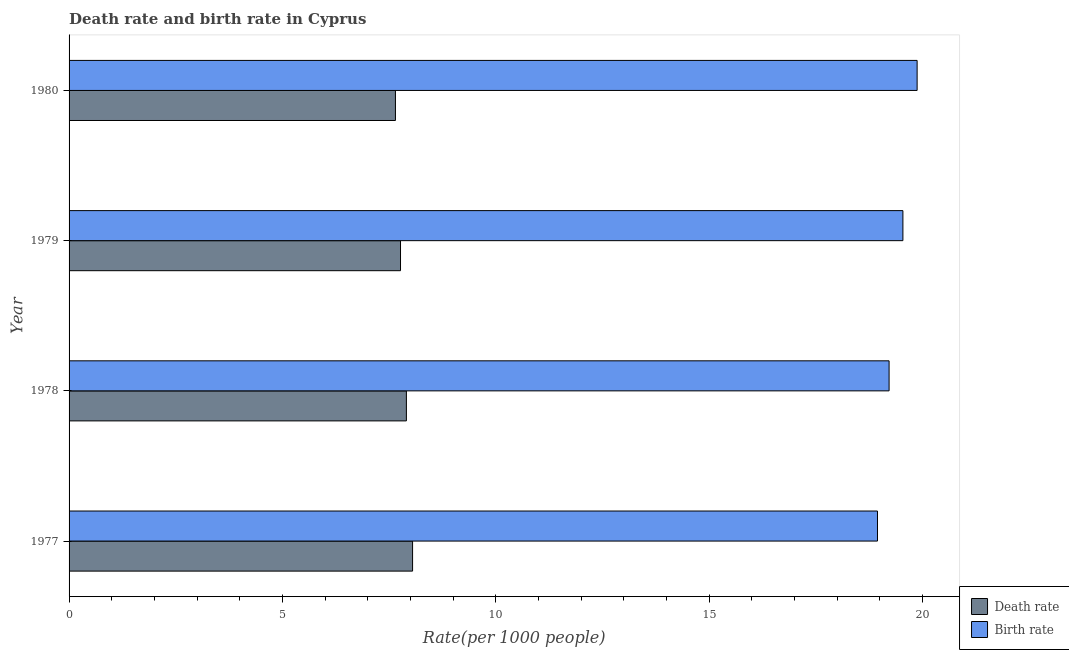Are the number of bars per tick equal to the number of legend labels?
Keep it short and to the point. Yes. Are the number of bars on each tick of the Y-axis equal?
Ensure brevity in your answer.  Yes. How many bars are there on the 2nd tick from the top?
Give a very brief answer. 2. What is the label of the 4th group of bars from the top?
Make the answer very short. 1977. What is the death rate in 1977?
Ensure brevity in your answer.  8.05. Across all years, what is the maximum birth rate?
Provide a short and direct response. 19.88. Across all years, what is the minimum birth rate?
Offer a very short reply. 18.95. In which year was the death rate minimum?
Your answer should be very brief. 1980. What is the total death rate in the graph?
Ensure brevity in your answer.  31.37. What is the difference between the birth rate in 1978 and that in 1979?
Provide a succinct answer. -0.32. What is the difference between the birth rate in 1980 and the death rate in 1978?
Provide a succinct answer. 11.97. What is the average death rate per year?
Provide a short and direct response. 7.84. In the year 1978, what is the difference between the death rate and birth rate?
Provide a short and direct response. -11.31. What is the ratio of the death rate in 1978 to that in 1979?
Offer a very short reply. 1.02. Is the difference between the birth rate in 1978 and 1980 greater than the difference between the death rate in 1978 and 1980?
Offer a very short reply. No. What is the difference between the highest and the second highest death rate?
Offer a terse response. 0.14. What is the difference between the highest and the lowest birth rate?
Your response must be concise. 0.93. In how many years, is the birth rate greater than the average birth rate taken over all years?
Your response must be concise. 2. What does the 1st bar from the top in 1979 represents?
Your response must be concise. Birth rate. What does the 2nd bar from the bottom in 1980 represents?
Offer a terse response. Birth rate. How many bars are there?
Keep it short and to the point. 8. Are all the bars in the graph horizontal?
Keep it short and to the point. Yes. Does the graph contain any zero values?
Ensure brevity in your answer.  No. Does the graph contain grids?
Your answer should be compact. No. What is the title of the graph?
Provide a short and direct response. Death rate and birth rate in Cyprus. What is the label or title of the X-axis?
Your answer should be very brief. Rate(per 1000 people). What is the label or title of the Y-axis?
Provide a short and direct response. Year. What is the Rate(per 1000 people) of Death rate in 1977?
Keep it short and to the point. 8.05. What is the Rate(per 1000 people) of Birth rate in 1977?
Give a very brief answer. 18.95. What is the Rate(per 1000 people) of Death rate in 1978?
Give a very brief answer. 7.91. What is the Rate(per 1000 people) of Birth rate in 1978?
Make the answer very short. 19.22. What is the Rate(per 1000 people) in Death rate in 1979?
Your answer should be compact. 7.77. What is the Rate(per 1000 people) in Birth rate in 1979?
Make the answer very short. 19.54. What is the Rate(per 1000 people) of Death rate in 1980?
Offer a terse response. 7.65. What is the Rate(per 1000 people) of Birth rate in 1980?
Offer a terse response. 19.88. Across all years, what is the maximum Rate(per 1000 people) in Death rate?
Provide a short and direct response. 8.05. Across all years, what is the maximum Rate(per 1000 people) in Birth rate?
Keep it short and to the point. 19.88. Across all years, what is the minimum Rate(per 1000 people) of Death rate?
Ensure brevity in your answer.  7.65. Across all years, what is the minimum Rate(per 1000 people) in Birth rate?
Provide a succinct answer. 18.95. What is the total Rate(per 1000 people) of Death rate in the graph?
Your response must be concise. 31.37. What is the total Rate(per 1000 people) of Birth rate in the graph?
Your answer should be compact. 77.58. What is the difference between the Rate(per 1000 people) in Death rate in 1977 and that in 1978?
Offer a terse response. 0.14. What is the difference between the Rate(per 1000 people) of Birth rate in 1977 and that in 1978?
Your response must be concise. -0.27. What is the difference between the Rate(per 1000 people) in Death rate in 1977 and that in 1979?
Give a very brief answer. 0.28. What is the difference between the Rate(per 1000 people) of Birth rate in 1977 and that in 1979?
Provide a short and direct response. -0.6. What is the difference between the Rate(per 1000 people) of Death rate in 1977 and that in 1980?
Offer a terse response. 0.4. What is the difference between the Rate(per 1000 people) in Birth rate in 1977 and that in 1980?
Your answer should be compact. -0.93. What is the difference between the Rate(per 1000 people) of Death rate in 1978 and that in 1979?
Offer a terse response. 0.14. What is the difference between the Rate(per 1000 people) of Birth rate in 1978 and that in 1979?
Your response must be concise. -0.32. What is the difference between the Rate(per 1000 people) in Death rate in 1978 and that in 1980?
Provide a short and direct response. 0.26. What is the difference between the Rate(per 1000 people) of Birth rate in 1978 and that in 1980?
Provide a succinct answer. -0.66. What is the difference between the Rate(per 1000 people) in Death rate in 1979 and that in 1980?
Ensure brevity in your answer.  0.12. What is the difference between the Rate(per 1000 people) of Birth rate in 1979 and that in 1980?
Provide a succinct answer. -0.33. What is the difference between the Rate(per 1000 people) of Death rate in 1977 and the Rate(per 1000 people) of Birth rate in 1978?
Ensure brevity in your answer.  -11.17. What is the difference between the Rate(per 1000 people) in Death rate in 1977 and the Rate(per 1000 people) in Birth rate in 1979?
Your response must be concise. -11.49. What is the difference between the Rate(per 1000 people) of Death rate in 1977 and the Rate(per 1000 people) of Birth rate in 1980?
Provide a short and direct response. -11.82. What is the difference between the Rate(per 1000 people) in Death rate in 1978 and the Rate(per 1000 people) in Birth rate in 1979?
Give a very brief answer. -11.64. What is the difference between the Rate(per 1000 people) of Death rate in 1978 and the Rate(per 1000 people) of Birth rate in 1980?
Offer a terse response. -11.97. What is the difference between the Rate(per 1000 people) in Death rate in 1979 and the Rate(per 1000 people) in Birth rate in 1980?
Give a very brief answer. -12.11. What is the average Rate(per 1000 people) in Death rate per year?
Your response must be concise. 7.84. What is the average Rate(per 1000 people) in Birth rate per year?
Make the answer very short. 19.4. In the year 1977, what is the difference between the Rate(per 1000 people) of Death rate and Rate(per 1000 people) of Birth rate?
Your response must be concise. -10.9. In the year 1978, what is the difference between the Rate(per 1000 people) of Death rate and Rate(per 1000 people) of Birth rate?
Offer a very short reply. -11.31. In the year 1979, what is the difference between the Rate(per 1000 people) of Death rate and Rate(per 1000 people) of Birth rate?
Provide a short and direct response. -11.78. In the year 1980, what is the difference between the Rate(per 1000 people) in Death rate and Rate(per 1000 people) in Birth rate?
Keep it short and to the point. -12.23. What is the ratio of the Rate(per 1000 people) of Death rate in 1977 to that in 1978?
Your answer should be compact. 1.02. What is the ratio of the Rate(per 1000 people) in Birth rate in 1977 to that in 1978?
Offer a very short reply. 0.99. What is the ratio of the Rate(per 1000 people) of Death rate in 1977 to that in 1979?
Ensure brevity in your answer.  1.04. What is the ratio of the Rate(per 1000 people) of Birth rate in 1977 to that in 1979?
Give a very brief answer. 0.97. What is the ratio of the Rate(per 1000 people) of Death rate in 1977 to that in 1980?
Your answer should be very brief. 1.05. What is the ratio of the Rate(per 1000 people) in Birth rate in 1977 to that in 1980?
Give a very brief answer. 0.95. What is the ratio of the Rate(per 1000 people) of Death rate in 1978 to that in 1979?
Provide a succinct answer. 1.02. What is the ratio of the Rate(per 1000 people) of Birth rate in 1978 to that in 1979?
Keep it short and to the point. 0.98. What is the ratio of the Rate(per 1000 people) in Death rate in 1978 to that in 1980?
Offer a terse response. 1.03. What is the ratio of the Rate(per 1000 people) in Birth rate in 1978 to that in 1980?
Your answer should be very brief. 0.97. What is the ratio of the Rate(per 1000 people) of Death rate in 1979 to that in 1980?
Provide a short and direct response. 1.02. What is the ratio of the Rate(per 1000 people) in Birth rate in 1979 to that in 1980?
Your response must be concise. 0.98. What is the difference between the highest and the second highest Rate(per 1000 people) of Death rate?
Offer a terse response. 0.14. What is the difference between the highest and the second highest Rate(per 1000 people) in Birth rate?
Offer a terse response. 0.33. What is the difference between the highest and the lowest Rate(per 1000 people) of Death rate?
Offer a terse response. 0.4. What is the difference between the highest and the lowest Rate(per 1000 people) of Birth rate?
Keep it short and to the point. 0.93. 